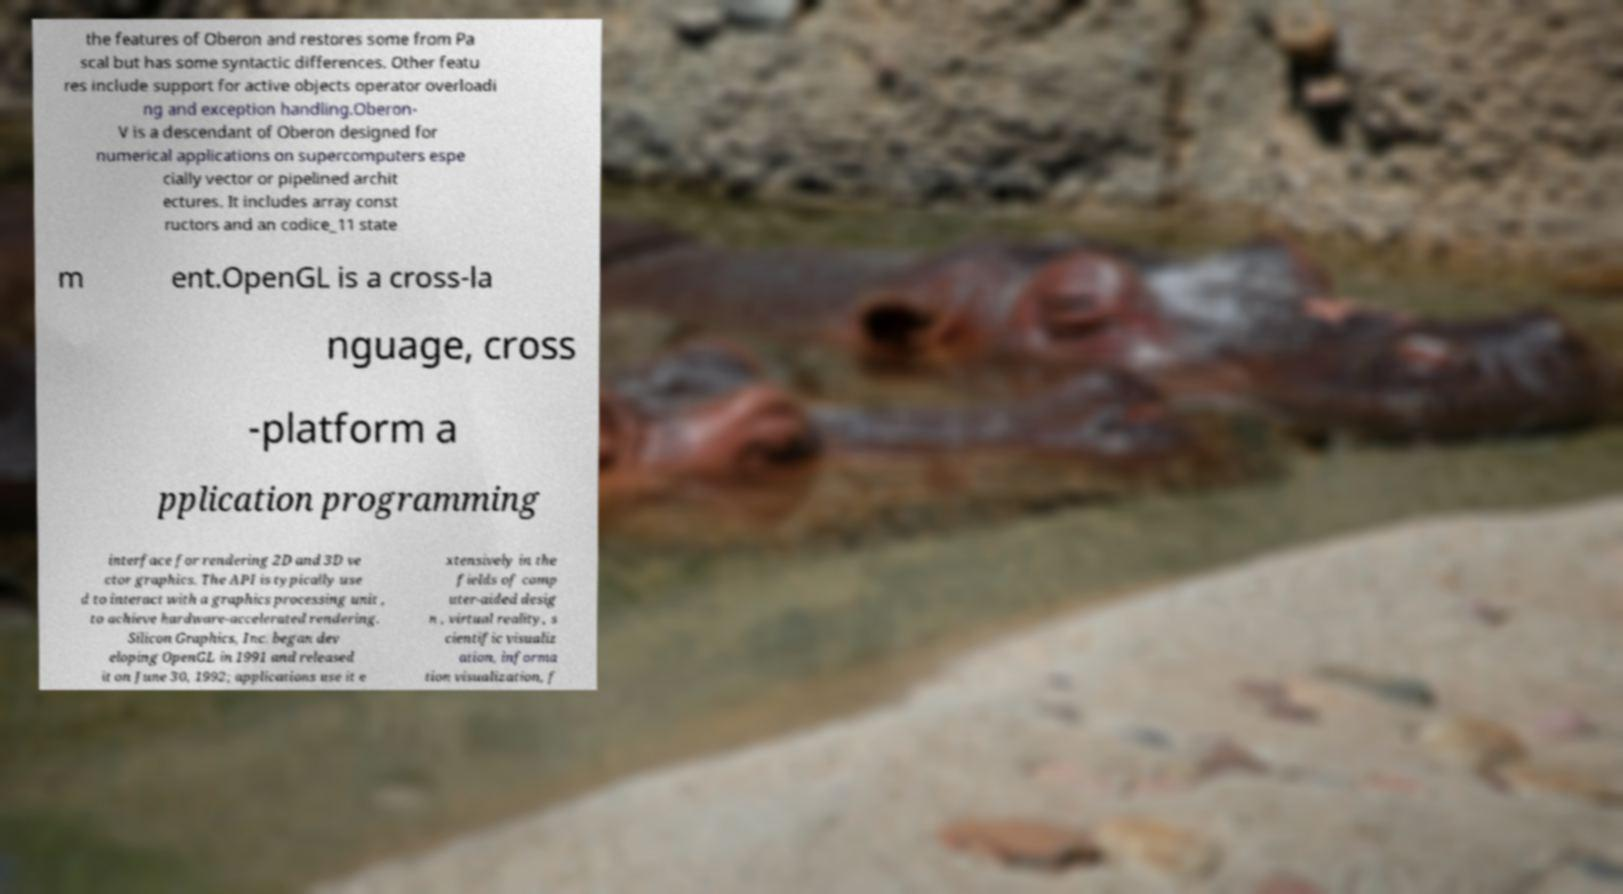Could you assist in decoding the text presented in this image and type it out clearly? the features of Oberon and restores some from Pa scal but has some syntactic differences. Other featu res include support for active objects operator overloadi ng and exception handling.Oberon- V is a descendant of Oberon designed for numerical applications on supercomputers espe cially vector or pipelined archit ectures. It includes array const ructors and an codice_11 state m ent.OpenGL is a cross-la nguage, cross -platform a pplication programming interface for rendering 2D and 3D ve ctor graphics. The API is typically use d to interact with a graphics processing unit , to achieve hardware-accelerated rendering. Silicon Graphics, Inc. began dev eloping OpenGL in 1991 and released it on June 30, 1992; applications use it e xtensively in the fields of comp uter-aided desig n , virtual reality, s cientific visualiz ation, informa tion visualization, f 